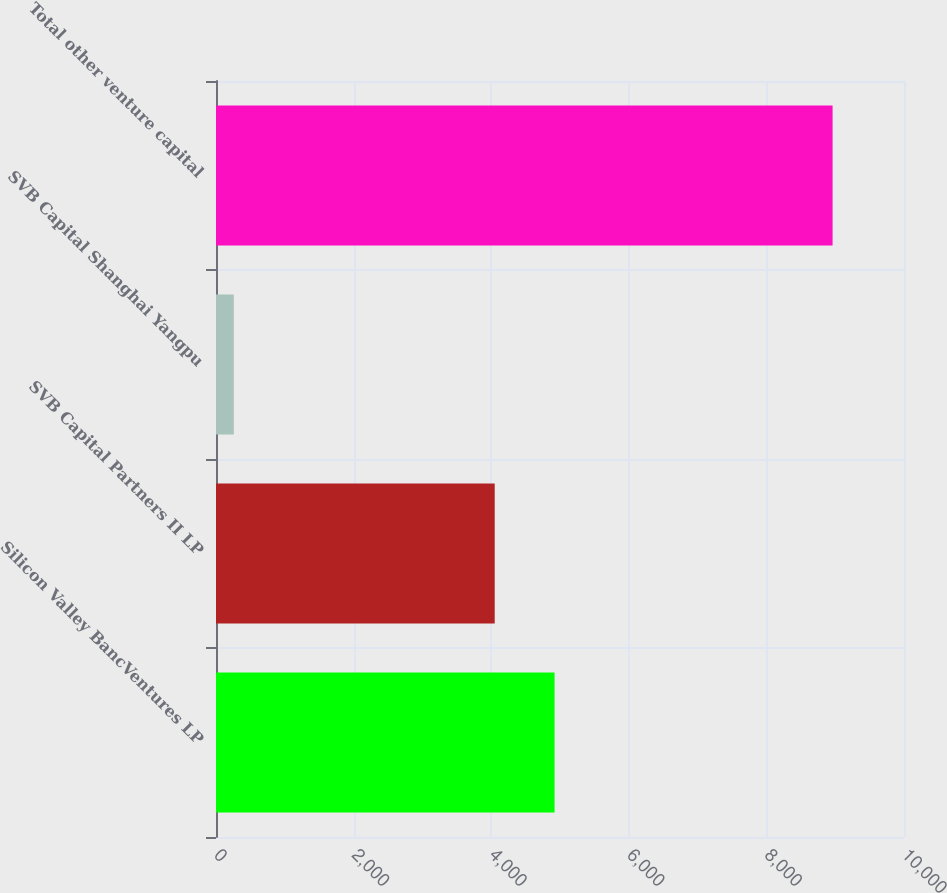Convert chart. <chart><loc_0><loc_0><loc_500><loc_500><bar_chart><fcel>Silicon Valley BancVentures LP<fcel>SVB Capital Partners II LP<fcel>SVB Capital Shanghai Yangpu<fcel>Total other venture capital<nl><fcel>4921.3<fcel>4051<fcel>259<fcel>8962<nl></chart> 